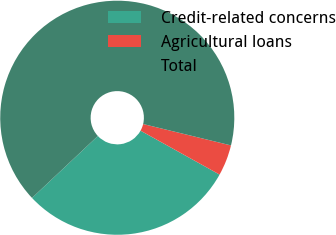<chart> <loc_0><loc_0><loc_500><loc_500><pie_chart><fcel>Credit-related concerns<fcel>Agricultural loans<fcel>Total<nl><fcel>29.91%<fcel>4.27%<fcel>65.81%<nl></chart> 